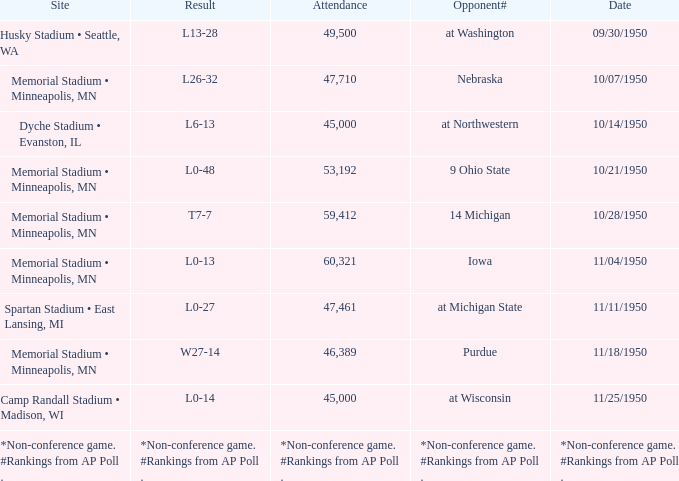What is the Date when the result is *non-conference game. #rankings from ap poll .? *Non-conference game. #Rankings from AP Poll . 